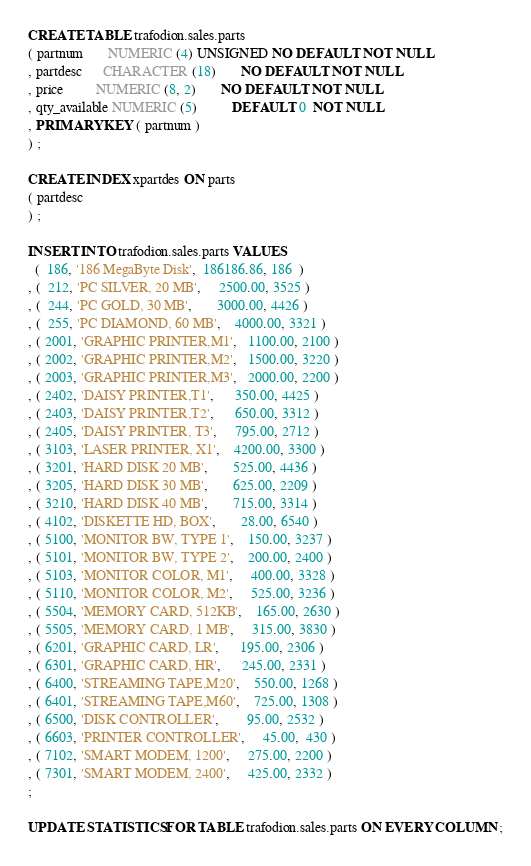<code> <loc_0><loc_0><loc_500><loc_500><_SQL_>CREATE TABLE trafodion.sales.parts
( partnum       NUMERIC (4) UNSIGNED NO DEFAULT NOT NULL
, partdesc      CHARACTER (18)       NO DEFAULT NOT NULL
, price         NUMERIC (8, 2)       NO DEFAULT NOT NULL
, qty_available NUMERIC (5)          DEFAULT 0  NOT NULL
, PRIMARY KEY ( partnum )
) ;

CREATE INDEX xpartdes ON parts
( partdesc
) ;

INSERT INTO trafodion.sales.parts VALUES
  (  186, '186 MegaByte Disk',  186186.86, 186  )
, (  212, 'PC SILVER, 20 MB',     2500.00, 3525 )
, (  244, 'PC GOLD, 30 MB',       3000.00, 4426 )
, (  255, 'PC DIAMOND, 60 MB',    4000.00, 3321 )
, ( 2001, 'GRAPHIC PRINTER,M1',   1100.00, 2100 )
, ( 2002, 'GRAPHIC PRINTER,M2',   1500.00, 3220 )
, ( 2003, 'GRAPHIC PRINTER,M3',   2000.00, 2200 )
, ( 2402, 'DAISY PRINTER,T1',      350.00, 4425 )
, ( 2403, 'DAISY PRINTER,T2',      650.00, 3312 )
, ( 2405, 'DAISY PRINTER, T3',     795.00, 2712 )
, ( 3103, 'LASER PRINTER, X1',    4200.00, 3300 )
, ( 3201, 'HARD DISK 20 MB',       525.00, 4436 )
, ( 3205, 'HARD DISK 30 MB',       625.00, 2209 )
, ( 3210, 'HARD DISK 40 MB',       715.00, 3314 )
, ( 4102, 'DISKETTE HD, BOX',       28.00, 6540 )
, ( 5100, 'MONITOR BW, TYPE 1',    150.00, 3237 )
, ( 5101, 'MONITOR BW, TYPE 2',    200.00, 2400 )
, ( 5103, 'MONITOR COLOR, M1',     400.00, 3328 )
, ( 5110, 'MONITOR COLOR, M2',     525.00, 3236 )
, ( 5504, 'MEMORY CARD, 512KB',    165.00, 2630 )
, ( 5505, 'MEMORY CARD, 1 MB',     315.00, 3830 )
, ( 6201, 'GRAPHIC CARD, LR',      195.00, 2306 )
, ( 6301, 'GRAPHIC CARD, HR',      245.00, 2331 )
, ( 6400, 'STREAMING TAPE,M20',    550.00, 1268 )
, ( 6401, 'STREAMING TAPE,M60',    725.00, 1308 )
, ( 6500, 'DISK CONTROLLER',        95.00, 2532 )
, ( 6603, 'PRINTER CONTROLLER',     45.00,  430 )
, ( 7102, 'SMART MODEM, 1200',     275.00, 2200 )
, ( 7301, 'SMART MODEM, 2400',     425.00, 2332 )
;

UPDATE STATISTICS FOR TABLE trafodion.sales.parts ON EVERY COLUMN ;
</code> 